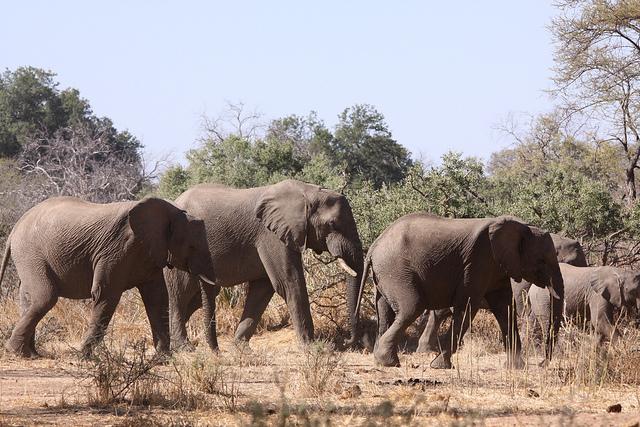How many total elephants are visible?
Keep it brief. 5. Which direction  are The elephants walking?
Concise answer only. Right. Do these animals have trunks?
Answer briefly. Yes. Is this in the wild?
Short answer required. Yes. 